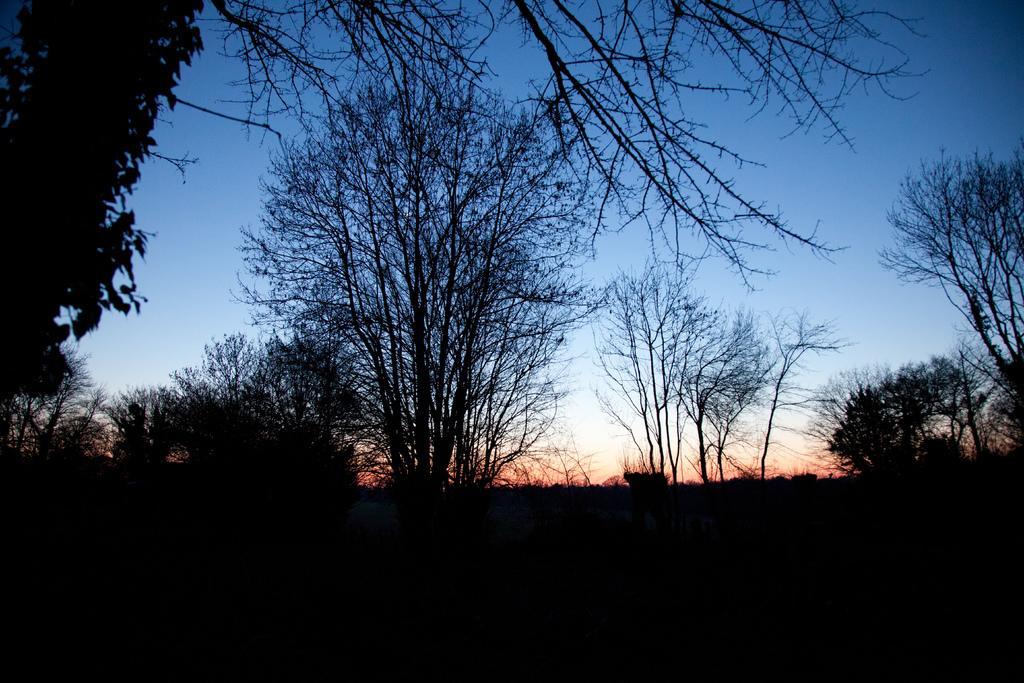Can you describe this image briefly? This image consists of trees. There is sky at the top. 